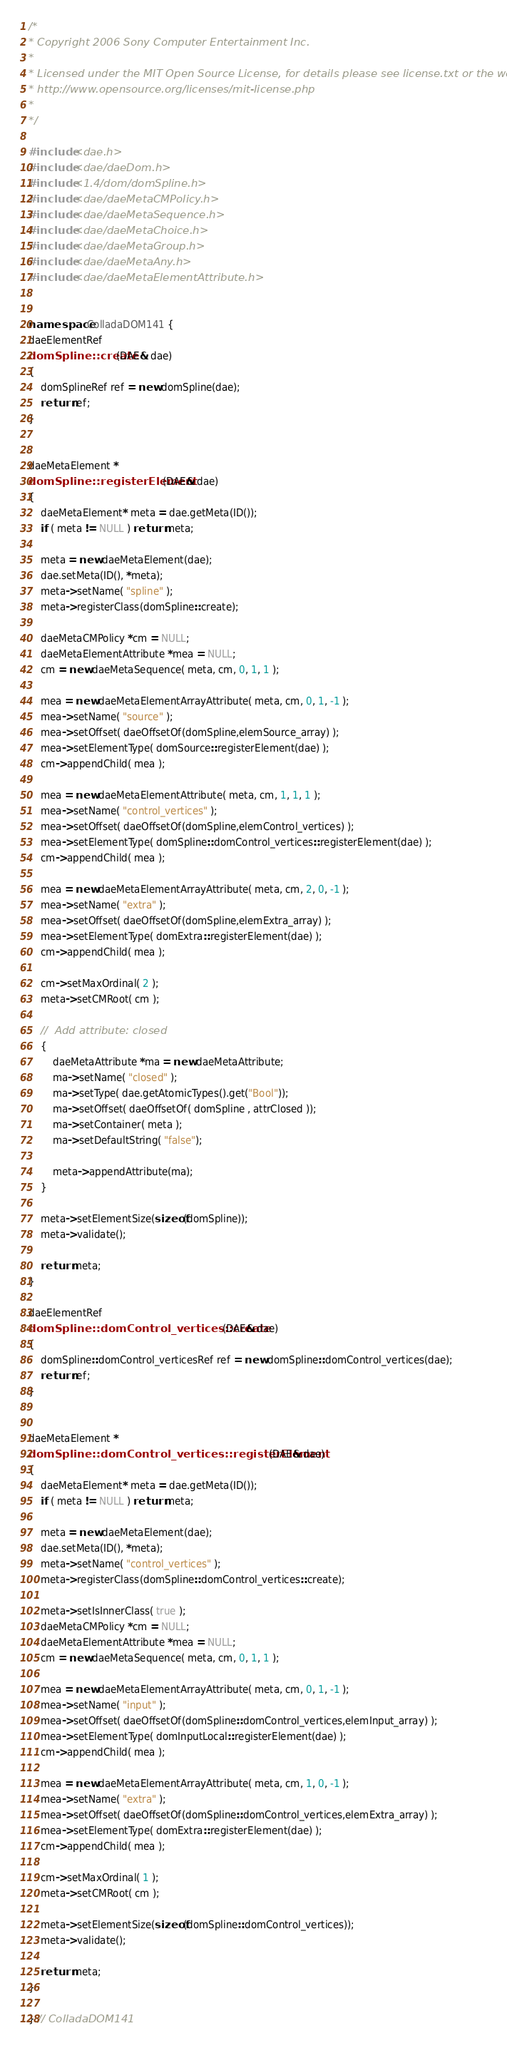<code> <loc_0><loc_0><loc_500><loc_500><_C++_>/*
* Copyright 2006 Sony Computer Entertainment Inc.
*
* Licensed under the MIT Open Source License, for details please see license.txt or the website
* http://www.opensource.org/licenses/mit-license.php
*
*/ 

#include <dae.h>
#include <dae/daeDom.h>
#include <1.4/dom/domSpline.h>
#include <dae/daeMetaCMPolicy.h>
#include <dae/daeMetaSequence.h>
#include <dae/daeMetaChoice.h>
#include <dae/daeMetaGroup.h>
#include <dae/daeMetaAny.h>
#include <dae/daeMetaElementAttribute.h>


namespace ColladaDOM141 {
daeElementRef
domSpline::create(DAE& dae)
{
	domSplineRef ref = new domSpline(dae);
	return ref;
}


daeMetaElement *
domSpline::registerElement(DAE& dae)
{
	daeMetaElement* meta = dae.getMeta(ID());
	if ( meta != NULL ) return meta;

	meta = new daeMetaElement(dae);
	dae.setMeta(ID(), *meta);
	meta->setName( "spline" );
	meta->registerClass(domSpline::create);

	daeMetaCMPolicy *cm = NULL;
	daeMetaElementAttribute *mea = NULL;
	cm = new daeMetaSequence( meta, cm, 0, 1, 1 );

	mea = new daeMetaElementArrayAttribute( meta, cm, 0, 1, -1 );
	mea->setName( "source" );
	mea->setOffset( daeOffsetOf(domSpline,elemSource_array) );
	mea->setElementType( domSource::registerElement(dae) );
	cm->appendChild( mea );

	mea = new daeMetaElementAttribute( meta, cm, 1, 1, 1 );
	mea->setName( "control_vertices" );
	mea->setOffset( daeOffsetOf(domSpline,elemControl_vertices) );
	mea->setElementType( domSpline::domControl_vertices::registerElement(dae) );
	cm->appendChild( mea );

	mea = new daeMetaElementArrayAttribute( meta, cm, 2, 0, -1 );
	mea->setName( "extra" );
	mea->setOffset( daeOffsetOf(domSpline,elemExtra_array) );
	mea->setElementType( domExtra::registerElement(dae) );
	cm->appendChild( mea );

	cm->setMaxOrdinal( 2 );
	meta->setCMRoot( cm );	

	//	Add attribute: closed
	{
		daeMetaAttribute *ma = new daeMetaAttribute;
		ma->setName( "closed" );
		ma->setType( dae.getAtomicTypes().get("Bool"));
		ma->setOffset( daeOffsetOf( domSpline , attrClosed ));
		ma->setContainer( meta );
		ma->setDefaultString( "false");
	
		meta->appendAttribute(ma);
	}

	meta->setElementSize(sizeof(domSpline));
	meta->validate();

	return meta;
}

daeElementRef
domSpline::domControl_vertices::create(DAE& dae)
{
	domSpline::domControl_verticesRef ref = new domSpline::domControl_vertices(dae);
	return ref;
}


daeMetaElement *
domSpline::domControl_vertices::registerElement(DAE& dae)
{
	daeMetaElement* meta = dae.getMeta(ID());
	if ( meta != NULL ) return meta;

	meta = new daeMetaElement(dae);
	dae.setMeta(ID(), *meta);
	meta->setName( "control_vertices" );
	meta->registerClass(domSpline::domControl_vertices::create);

	meta->setIsInnerClass( true );
	daeMetaCMPolicy *cm = NULL;
	daeMetaElementAttribute *mea = NULL;
	cm = new daeMetaSequence( meta, cm, 0, 1, 1 );

	mea = new daeMetaElementArrayAttribute( meta, cm, 0, 1, -1 );
	mea->setName( "input" );
	mea->setOffset( daeOffsetOf(domSpline::domControl_vertices,elemInput_array) );
	mea->setElementType( domInputLocal::registerElement(dae) );
	cm->appendChild( mea );

	mea = new daeMetaElementArrayAttribute( meta, cm, 1, 0, -1 );
	mea->setName( "extra" );
	mea->setOffset( daeOffsetOf(domSpline::domControl_vertices,elemExtra_array) );
	mea->setElementType( domExtra::registerElement(dae) );
	cm->appendChild( mea );

	cm->setMaxOrdinal( 1 );
	meta->setCMRoot( cm );	

	meta->setElementSize(sizeof(domSpline::domControl_vertices));
	meta->validate();

	return meta;
}

} // ColladaDOM141
</code> 